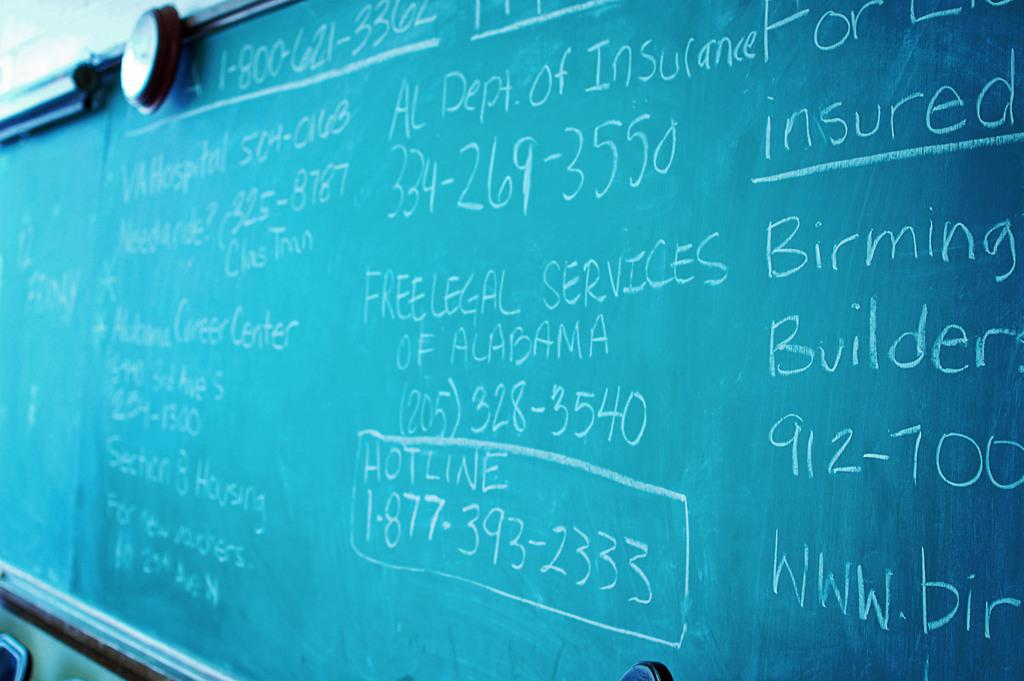<image>
Summarize the visual content of the image. A chalkboard has a lot of information about Alabama services written on it. 